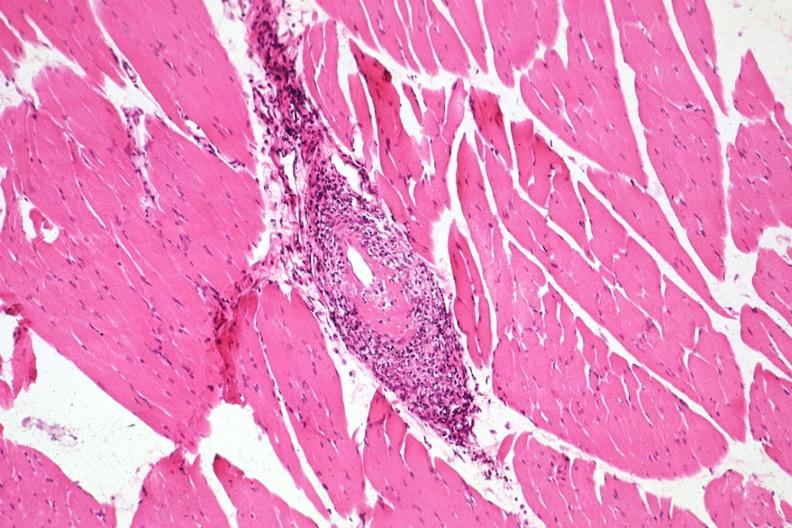what is present?
Answer the question using a single word or phrase. Muscle 